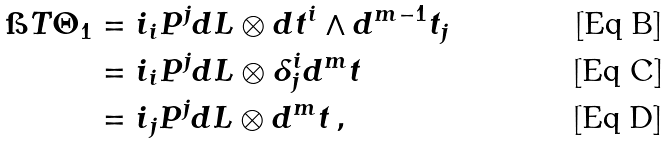<formula> <loc_0><loc_0><loc_500><loc_500>\i T \Theta _ { 1 } & = i _ { i } P ^ { j } d L \otimes d t ^ { i } \wedge d ^ { m - 1 } t _ { j } \\ & = i _ { i } P ^ { j } d L \otimes \delta ^ { i } _ { j } d ^ { m } t \\ & = i _ { j } P ^ { j } d L \otimes d ^ { m } t \, ,</formula> 